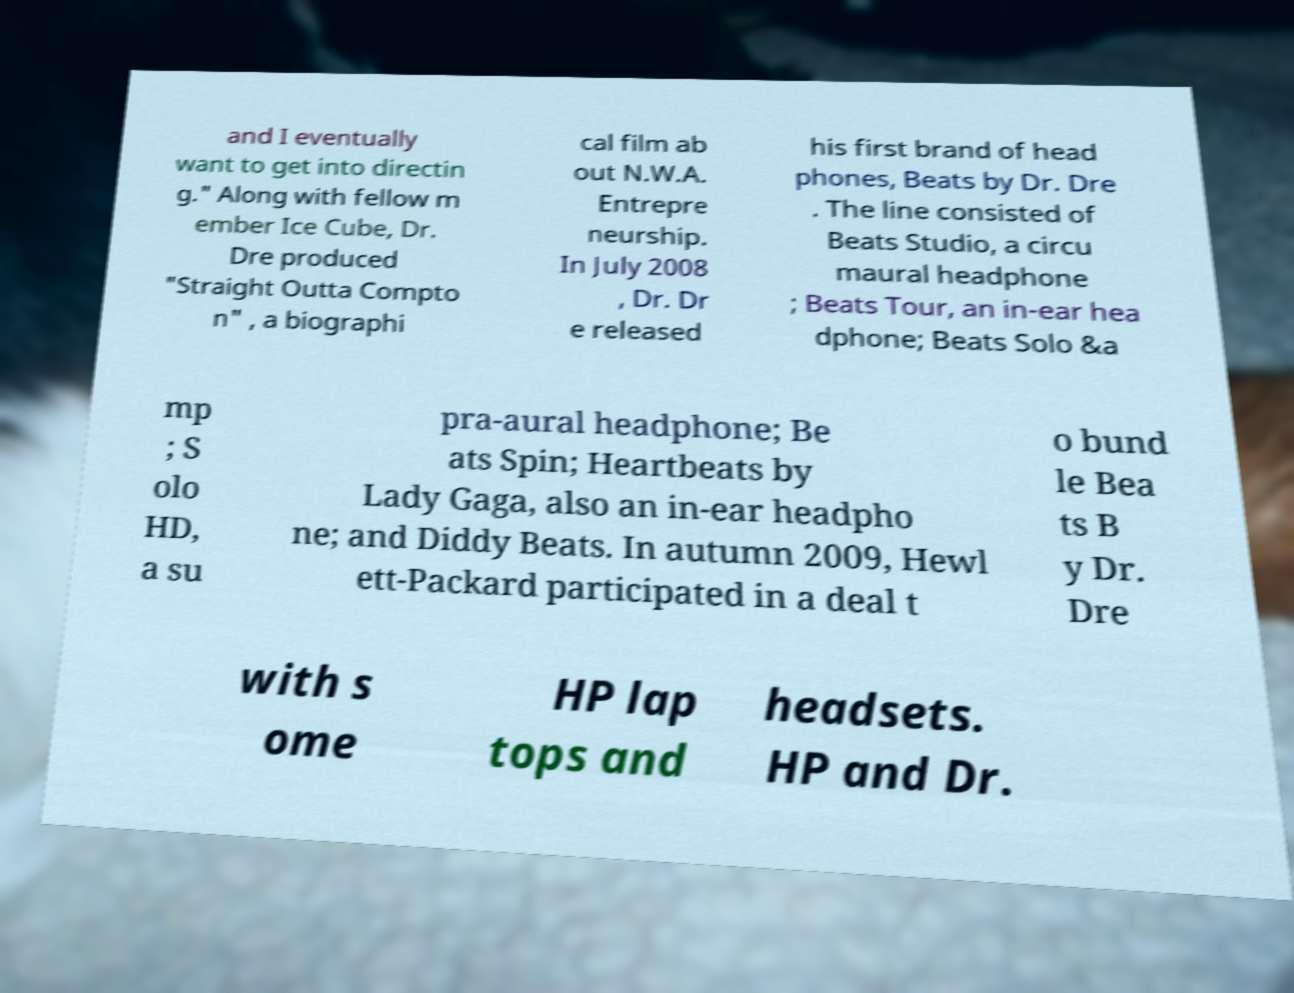There's text embedded in this image that I need extracted. Can you transcribe it verbatim? and I eventually want to get into directin g." Along with fellow m ember Ice Cube, Dr. Dre produced "Straight Outta Compto n" , a biographi cal film ab out N.W.A. Entrepre neurship. In July 2008 , Dr. Dr e released his first brand of head phones, Beats by Dr. Dre . The line consisted of Beats Studio, a circu maural headphone ; Beats Tour, an in-ear hea dphone; Beats Solo &a mp ; S olo HD, a su pra-aural headphone; Be ats Spin; Heartbeats by Lady Gaga, also an in-ear headpho ne; and Diddy Beats. In autumn 2009, Hewl ett-Packard participated in a deal t o bund le Bea ts B y Dr. Dre with s ome HP lap tops and headsets. HP and Dr. 